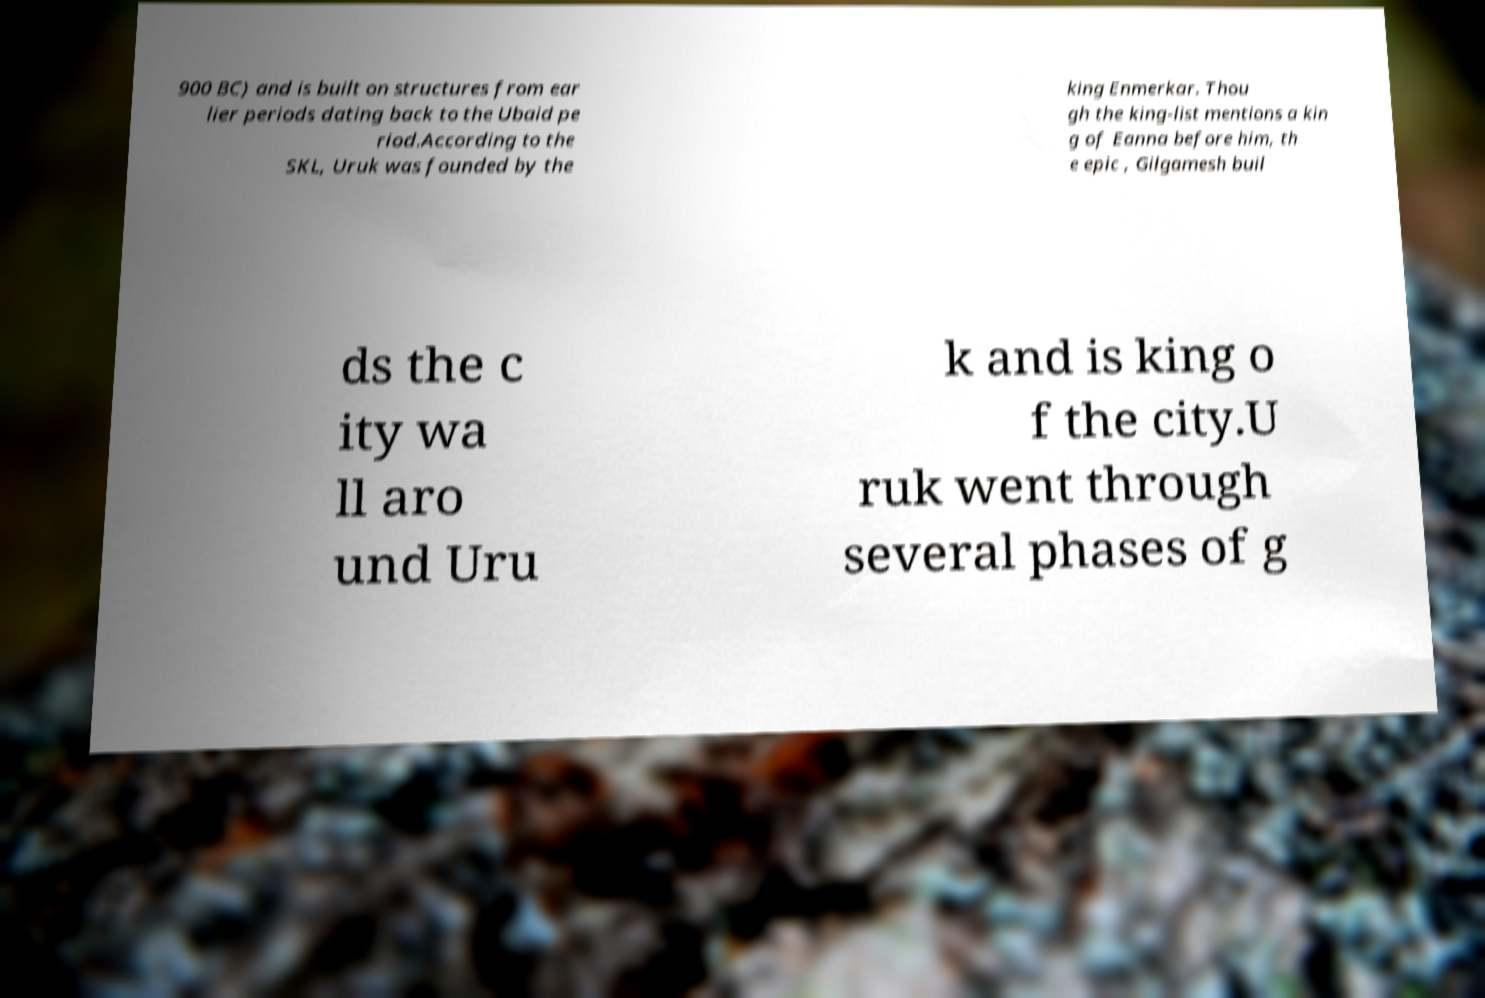Can you accurately transcribe the text from the provided image for me? 900 BC) and is built on structures from ear lier periods dating back to the Ubaid pe riod.According to the SKL, Uruk was founded by the king Enmerkar. Thou gh the king-list mentions a kin g of Eanna before him, th e epic , Gilgamesh buil ds the c ity wa ll aro und Uru k and is king o f the city.U ruk went through several phases of g 